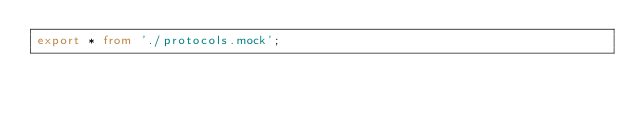<code> <loc_0><loc_0><loc_500><loc_500><_TypeScript_>export * from './protocols.mock';
</code> 